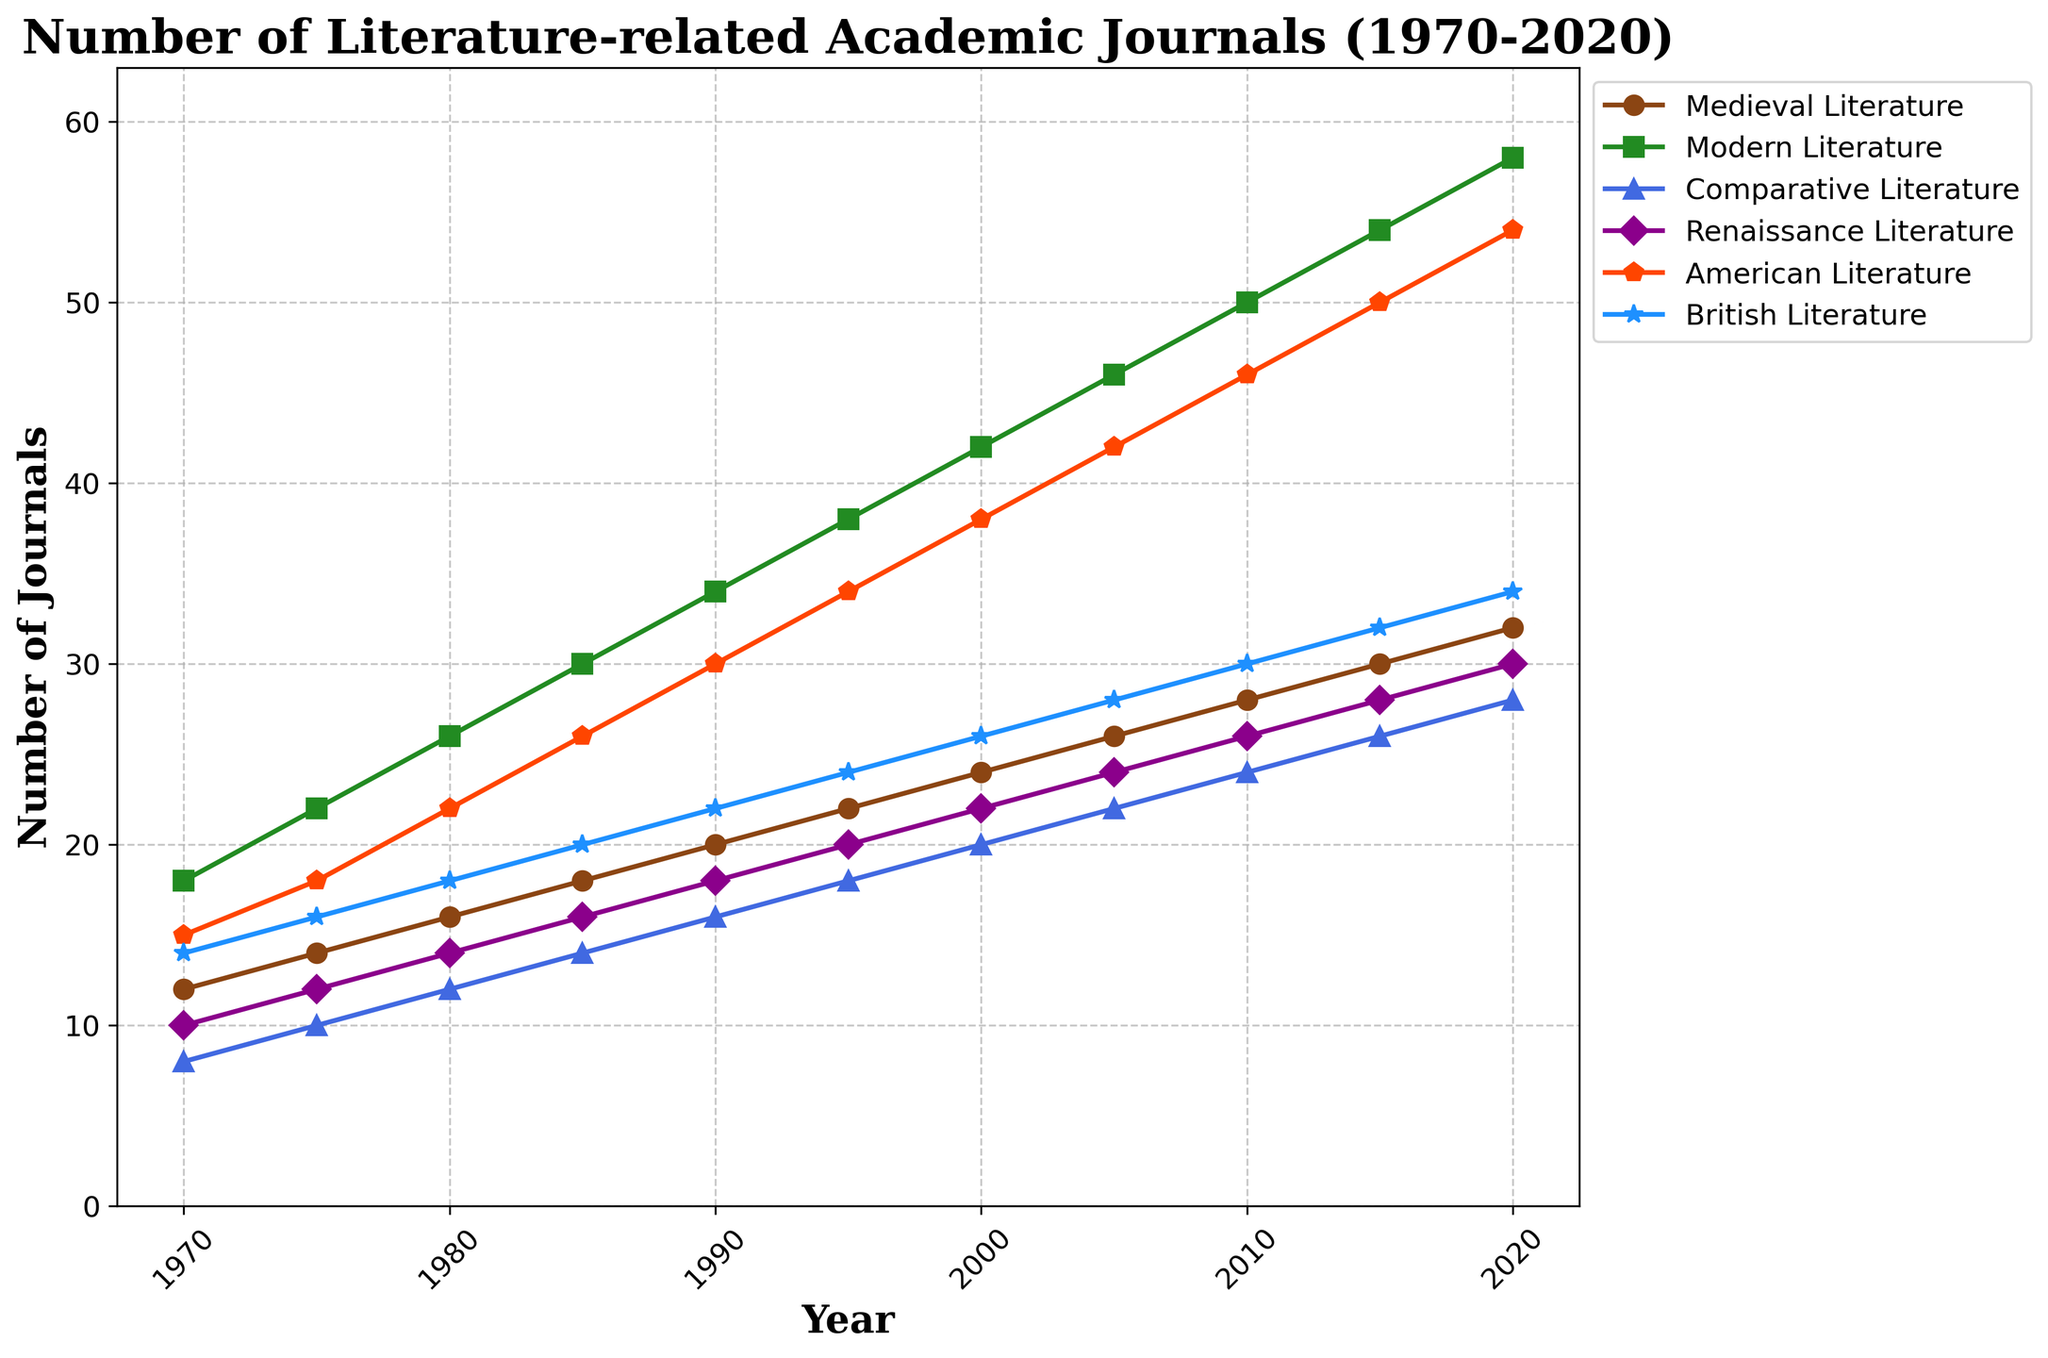What is the overall trend of journals related to Modern Literature from 1970 to 2020? The number of journals related to Modern Literature increases consistently from 1970 to 2020. Starting from 18 in 1970 and reaching 58 in 2020, the trend shows steady growth.
Answer: An increasing trend Which subfield had the highest number of academic journals published in 2020? In 2020, the subfield with the highest number of journals is Modern Literature, represented by the point with the highest y-value.
Answer: Modern Literature How many more American Literature journals were published in 2015 compared to 1970? Subtract the number of American Literature journals in 1970 (15) from the number in 2015 (50). \(50 - 15 = 35\)
Answer: 35 Which subfield had the least number of journals in 1980, and how many were there? In 1980, Comparative Literature had the least number of journals, indicated by the lowest data point among subfields for that year (12).
Answer: Comparative Literature, 12 What is the average number of British Literature journals published annually across the 1970s and 1980s? Sum the number of British Literature journals from 1970, 1975, 1980, 1985 (14+16+18+20 = 68) and divide by 4. \(68 / 4 = 17\)
Answer: 17 Which subfield consistently had the second-highest number of journals published from 1970 to 2020? American Literature consistently has the second-highest number of journals, considering the visual markers for each year.
Answer: American Literature Did any subfield ever have a decrease in the number of journals published from one 5-year interval to the next? All subfields show a consistent increase in the number of journals published over each 5-year interval. By comparing the markers between intervals, no decrease is observed.
Answer: No What is the difference in the number of Comparative Literature journals published between 2000 and 2020? Subtract the number of Comparative Literature journals in 2000 (20) from the number in 2020 (28). \(28 - 20 = 8\)
Answer: 8 By how many journals did the Medieval Literature category grow from 1970 to 2020? Subtract the number of Medieval Literature journals in 1970 (12) from the number in 2020 (32). \(32 - 12 = 20\)
Answer: 20 In what year did British Literature journals surpass Renaissance Literature journals, and how many were published that year in British Literature? In 1970 and 1975, British Literature journals are more than Renaissance Literature journals. In 1970, British Literature journals are 14, and Renaissance Literature journals are 10. Thus, 1970 is the first occurrence.
Answer: 1970, 14 